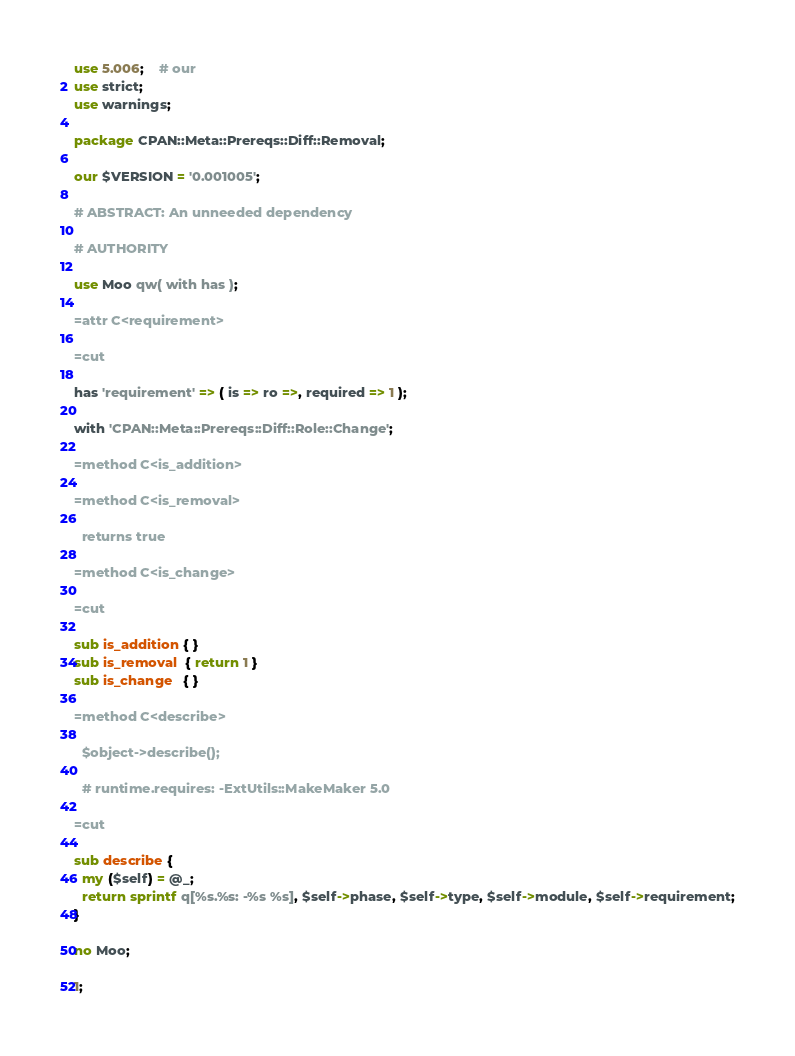<code> <loc_0><loc_0><loc_500><loc_500><_Perl_>use 5.006;    # our
use strict;
use warnings;

package CPAN::Meta::Prereqs::Diff::Removal;

our $VERSION = '0.001005';

# ABSTRACT: An unneeded dependency

# AUTHORITY

use Moo qw( with has );

=attr C<requirement>

=cut

has 'requirement' => ( is => ro =>, required => 1 );

with 'CPAN::Meta::Prereqs::Diff::Role::Change';

=method C<is_addition>

=method C<is_removal>

  returns true

=method C<is_change>

=cut

sub is_addition { }
sub is_removal  { return 1 }
sub is_change   { }

=method C<describe>

  $object->describe();

  # runtime.requires: -ExtUtils::MakeMaker 5.0

=cut

sub describe {
  my ($self) = @_;
  return sprintf q[%s.%s: -%s %s], $self->phase, $self->type, $self->module, $self->requirement;
}

no Moo;

1;

</code> 